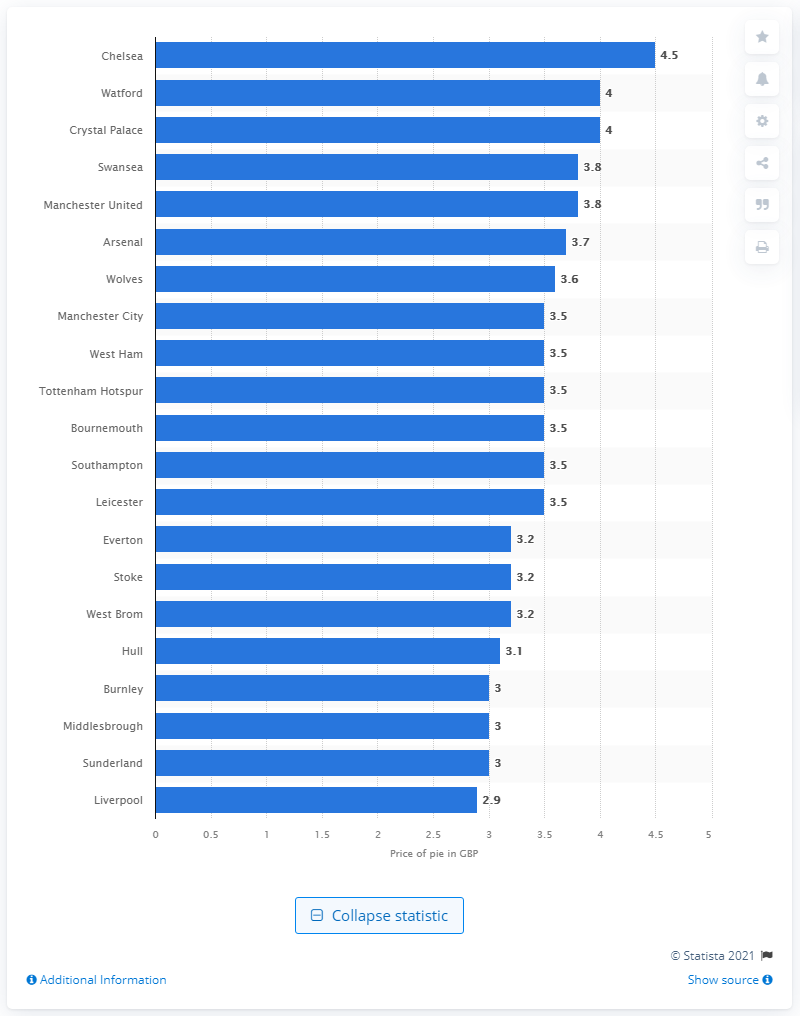Identify some key points in this picture. Chelsea was the team that sold the most expensive pie during the 2019/20 season. 